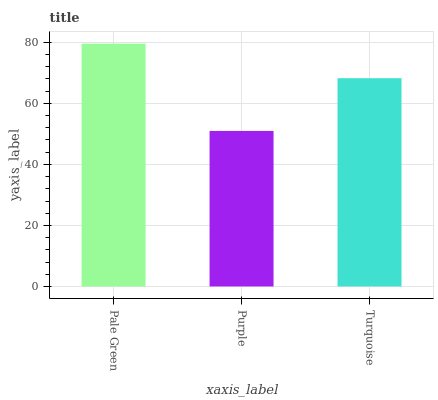Is Purple the minimum?
Answer yes or no. Yes. Is Pale Green the maximum?
Answer yes or no. Yes. Is Turquoise the minimum?
Answer yes or no. No. Is Turquoise the maximum?
Answer yes or no. No. Is Turquoise greater than Purple?
Answer yes or no. Yes. Is Purple less than Turquoise?
Answer yes or no. Yes. Is Purple greater than Turquoise?
Answer yes or no. No. Is Turquoise less than Purple?
Answer yes or no. No. Is Turquoise the high median?
Answer yes or no. Yes. Is Turquoise the low median?
Answer yes or no. Yes. Is Purple the high median?
Answer yes or no. No. Is Purple the low median?
Answer yes or no. No. 